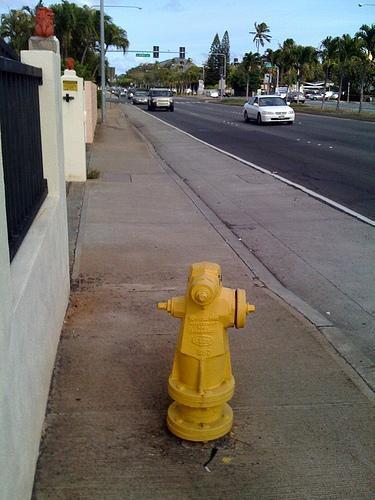How many people are wearing white shirts?
Give a very brief answer. 0. 